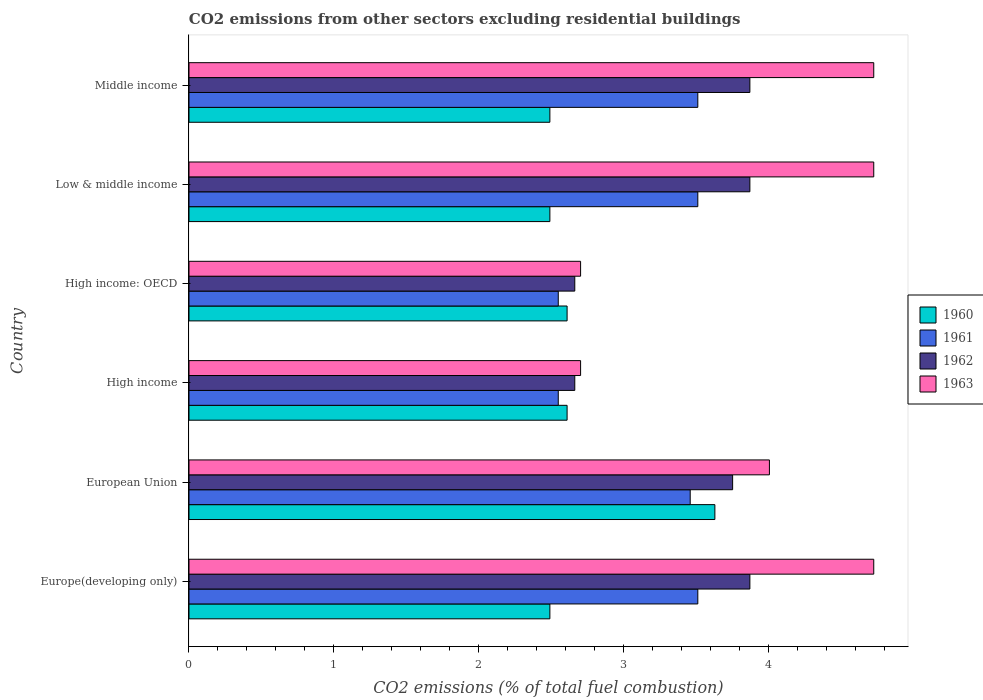How many different coloured bars are there?
Ensure brevity in your answer.  4. How many groups of bars are there?
Your answer should be compact. 6. Are the number of bars on each tick of the Y-axis equal?
Offer a terse response. Yes. How many bars are there on the 4th tick from the top?
Offer a terse response. 4. What is the label of the 1st group of bars from the top?
Make the answer very short. Middle income. What is the total CO2 emitted in 1961 in Middle income?
Provide a succinct answer. 3.51. Across all countries, what is the maximum total CO2 emitted in 1961?
Give a very brief answer. 3.51. Across all countries, what is the minimum total CO2 emitted in 1961?
Provide a short and direct response. 2.55. In which country was the total CO2 emitted in 1961 maximum?
Your response must be concise. Europe(developing only). What is the total total CO2 emitted in 1962 in the graph?
Keep it short and to the point. 20.69. What is the difference between the total CO2 emitted in 1960 in Europe(developing only) and that in High income: OECD?
Your response must be concise. -0.12. What is the difference between the total CO2 emitted in 1962 in High income and the total CO2 emitted in 1961 in Middle income?
Offer a terse response. -0.85. What is the average total CO2 emitted in 1963 per country?
Ensure brevity in your answer.  3.93. What is the difference between the total CO2 emitted in 1961 and total CO2 emitted in 1963 in European Union?
Offer a terse response. -0.55. What is the ratio of the total CO2 emitted in 1963 in High income: OECD to that in Low & middle income?
Provide a succinct answer. 0.57. Is the total CO2 emitted in 1961 in Europe(developing only) less than that in High income?
Make the answer very short. No. Is the difference between the total CO2 emitted in 1961 in European Union and Low & middle income greater than the difference between the total CO2 emitted in 1963 in European Union and Low & middle income?
Ensure brevity in your answer.  Yes. What is the difference between the highest and the second highest total CO2 emitted in 1963?
Offer a terse response. 0. What is the difference between the highest and the lowest total CO2 emitted in 1961?
Your answer should be compact. 0.96. In how many countries, is the total CO2 emitted in 1962 greater than the average total CO2 emitted in 1962 taken over all countries?
Offer a terse response. 4. Is it the case that in every country, the sum of the total CO2 emitted in 1962 and total CO2 emitted in 1961 is greater than the sum of total CO2 emitted in 1960 and total CO2 emitted in 1963?
Ensure brevity in your answer.  No. What does the 4th bar from the bottom in Europe(developing only) represents?
Ensure brevity in your answer.  1963. How many bars are there?
Offer a terse response. 24. How many countries are there in the graph?
Give a very brief answer. 6. What is the difference between two consecutive major ticks on the X-axis?
Your response must be concise. 1. Are the values on the major ticks of X-axis written in scientific E-notation?
Make the answer very short. No. Does the graph contain any zero values?
Offer a very short reply. No. Where does the legend appear in the graph?
Your response must be concise. Center right. How many legend labels are there?
Offer a terse response. 4. What is the title of the graph?
Your response must be concise. CO2 emissions from other sectors excluding residential buildings. Does "1967" appear as one of the legend labels in the graph?
Provide a succinct answer. No. What is the label or title of the X-axis?
Keep it short and to the point. CO2 emissions (% of total fuel combustion). What is the CO2 emissions (% of total fuel combustion) of 1960 in Europe(developing only)?
Offer a terse response. 2.49. What is the CO2 emissions (% of total fuel combustion) in 1961 in Europe(developing only)?
Your answer should be compact. 3.51. What is the CO2 emissions (% of total fuel combustion) in 1962 in Europe(developing only)?
Your response must be concise. 3.87. What is the CO2 emissions (% of total fuel combustion) of 1963 in Europe(developing only)?
Provide a short and direct response. 4.73. What is the CO2 emissions (% of total fuel combustion) of 1960 in European Union?
Provide a short and direct response. 3.63. What is the CO2 emissions (% of total fuel combustion) in 1961 in European Union?
Provide a short and direct response. 3.46. What is the CO2 emissions (% of total fuel combustion) of 1962 in European Union?
Ensure brevity in your answer.  3.75. What is the CO2 emissions (% of total fuel combustion) of 1963 in European Union?
Keep it short and to the point. 4.01. What is the CO2 emissions (% of total fuel combustion) in 1960 in High income?
Your answer should be compact. 2.61. What is the CO2 emissions (% of total fuel combustion) in 1961 in High income?
Your response must be concise. 2.55. What is the CO2 emissions (% of total fuel combustion) in 1962 in High income?
Make the answer very short. 2.66. What is the CO2 emissions (% of total fuel combustion) in 1963 in High income?
Your answer should be compact. 2.7. What is the CO2 emissions (% of total fuel combustion) of 1960 in High income: OECD?
Your answer should be compact. 2.61. What is the CO2 emissions (% of total fuel combustion) of 1961 in High income: OECD?
Make the answer very short. 2.55. What is the CO2 emissions (% of total fuel combustion) in 1962 in High income: OECD?
Provide a short and direct response. 2.66. What is the CO2 emissions (% of total fuel combustion) of 1963 in High income: OECD?
Make the answer very short. 2.7. What is the CO2 emissions (% of total fuel combustion) of 1960 in Low & middle income?
Your response must be concise. 2.49. What is the CO2 emissions (% of total fuel combustion) in 1961 in Low & middle income?
Keep it short and to the point. 3.51. What is the CO2 emissions (% of total fuel combustion) of 1962 in Low & middle income?
Make the answer very short. 3.87. What is the CO2 emissions (% of total fuel combustion) of 1963 in Low & middle income?
Make the answer very short. 4.73. What is the CO2 emissions (% of total fuel combustion) of 1960 in Middle income?
Offer a terse response. 2.49. What is the CO2 emissions (% of total fuel combustion) of 1961 in Middle income?
Ensure brevity in your answer.  3.51. What is the CO2 emissions (% of total fuel combustion) of 1962 in Middle income?
Your response must be concise. 3.87. What is the CO2 emissions (% of total fuel combustion) in 1963 in Middle income?
Provide a succinct answer. 4.73. Across all countries, what is the maximum CO2 emissions (% of total fuel combustion) in 1960?
Keep it short and to the point. 3.63. Across all countries, what is the maximum CO2 emissions (% of total fuel combustion) of 1961?
Keep it short and to the point. 3.51. Across all countries, what is the maximum CO2 emissions (% of total fuel combustion) of 1962?
Offer a terse response. 3.87. Across all countries, what is the maximum CO2 emissions (% of total fuel combustion) of 1963?
Provide a succinct answer. 4.73. Across all countries, what is the minimum CO2 emissions (% of total fuel combustion) in 1960?
Offer a very short reply. 2.49. Across all countries, what is the minimum CO2 emissions (% of total fuel combustion) of 1961?
Give a very brief answer. 2.55. Across all countries, what is the minimum CO2 emissions (% of total fuel combustion) of 1962?
Your response must be concise. 2.66. Across all countries, what is the minimum CO2 emissions (% of total fuel combustion) of 1963?
Provide a succinct answer. 2.7. What is the total CO2 emissions (% of total fuel combustion) in 1960 in the graph?
Make the answer very short. 16.32. What is the total CO2 emissions (% of total fuel combustion) in 1961 in the graph?
Your response must be concise. 19.09. What is the total CO2 emissions (% of total fuel combustion) of 1962 in the graph?
Provide a short and direct response. 20.69. What is the total CO2 emissions (% of total fuel combustion) in 1963 in the graph?
Provide a succinct answer. 23.59. What is the difference between the CO2 emissions (% of total fuel combustion) in 1960 in Europe(developing only) and that in European Union?
Provide a succinct answer. -1.14. What is the difference between the CO2 emissions (% of total fuel combustion) of 1961 in Europe(developing only) and that in European Union?
Provide a short and direct response. 0.05. What is the difference between the CO2 emissions (% of total fuel combustion) in 1962 in Europe(developing only) and that in European Union?
Provide a short and direct response. 0.12. What is the difference between the CO2 emissions (% of total fuel combustion) of 1963 in Europe(developing only) and that in European Union?
Offer a very short reply. 0.72. What is the difference between the CO2 emissions (% of total fuel combustion) of 1960 in Europe(developing only) and that in High income?
Offer a terse response. -0.12. What is the difference between the CO2 emissions (% of total fuel combustion) of 1961 in Europe(developing only) and that in High income?
Give a very brief answer. 0.96. What is the difference between the CO2 emissions (% of total fuel combustion) in 1962 in Europe(developing only) and that in High income?
Offer a terse response. 1.21. What is the difference between the CO2 emissions (% of total fuel combustion) of 1963 in Europe(developing only) and that in High income?
Offer a terse response. 2.02. What is the difference between the CO2 emissions (% of total fuel combustion) of 1960 in Europe(developing only) and that in High income: OECD?
Make the answer very short. -0.12. What is the difference between the CO2 emissions (% of total fuel combustion) of 1961 in Europe(developing only) and that in High income: OECD?
Offer a terse response. 0.96. What is the difference between the CO2 emissions (% of total fuel combustion) in 1962 in Europe(developing only) and that in High income: OECD?
Make the answer very short. 1.21. What is the difference between the CO2 emissions (% of total fuel combustion) in 1963 in Europe(developing only) and that in High income: OECD?
Give a very brief answer. 2.02. What is the difference between the CO2 emissions (% of total fuel combustion) of 1960 in Europe(developing only) and that in Low & middle income?
Provide a succinct answer. 0. What is the difference between the CO2 emissions (% of total fuel combustion) of 1962 in Europe(developing only) and that in Low & middle income?
Make the answer very short. 0. What is the difference between the CO2 emissions (% of total fuel combustion) of 1963 in Europe(developing only) and that in Low & middle income?
Provide a succinct answer. 0. What is the difference between the CO2 emissions (% of total fuel combustion) in 1961 in Europe(developing only) and that in Middle income?
Make the answer very short. 0. What is the difference between the CO2 emissions (% of total fuel combustion) of 1962 in Europe(developing only) and that in Middle income?
Give a very brief answer. 0. What is the difference between the CO2 emissions (% of total fuel combustion) in 1960 in European Union and that in High income?
Offer a very short reply. 1.02. What is the difference between the CO2 emissions (% of total fuel combustion) of 1961 in European Union and that in High income?
Give a very brief answer. 0.91. What is the difference between the CO2 emissions (% of total fuel combustion) of 1962 in European Union and that in High income?
Keep it short and to the point. 1.09. What is the difference between the CO2 emissions (% of total fuel combustion) of 1963 in European Union and that in High income?
Ensure brevity in your answer.  1.3. What is the difference between the CO2 emissions (% of total fuel combustion) of 1960 in European Union and that in High income: OECD?
Provide a short and direct response. 1.02. What is the difference between the CO2 emissions (% of total fuel combustion) in 1961 in European Union and that in High income: OECD?
Provide a succinct answer. 0.91. What is the difference between the CO2 emissions (% of total fuel combustion) in 1962 in European Union and that in High income: OECD?
Give a very brief answer. 1.09. What is the difference between the CO2 emissions (% of total fuel combustion) in 1963 in European Union and that in High income: OECD?
Offer a very short reply. 1.3. What is the difference between the CO2 emissions (% of total fuel combustion) in 1960 in European Union and that in Low & middle income?
Your answer should be very brief. 1.14. What is the difference between the CO2 emissions (% of total fuel combustion) of 1961 in European Union and that in Low & middle income?
Your answer should be compact. -0.05. What is the difference between the CO2 emissions (% of total fuel combustion) of 1962 in European Union and that in Low & middle income?
Keep it short and to the point. -0.12. What is the difference between the CO2 emissions (% of total fuel combustion) of 1963 in European Union and that in Low & middle income?
Make the answer very short. -0.72. What is the difference between the CO2 emissions (% of total fuel combustion) of 1960 in European Union and that in Middle income?
Offer a terse response. 1.14. What is the difference between the CO2 emissions (% of total fuel combustion) of 1961 in European Union and that in Middle income?
Keep it short and to the point. -0.05. What is the difference between the CO2 emissions (% of total fuel combustion) in 1962 in European Union and that in Middle income?
Offer a terse response. -0.12. What is the difference between the CO2 emissions (% of total fuel combustion) of 1963 in European Union and that in Middle income?
Give a very brief answer. -0.72. What is the difference between the CO2 emissions (% of total fuel combustion) of 1960 in High income and that in High income: OECD?
Provide a succinct answer. 0. What is the difference between the CO2 emissions (% of total fuel combustion) of 1962 in High income and that in High income: OECD?
Your answer should be very brief. 0. What is the difference between the CO2 emissions (% of total fuel combustion) in 1963 in High income and that in High income: OECD?
Your answer should be very brief. 0. What is the difference between the CO2 emissions (% of total fuel combustion) of 1960 in High income and that in Low & middle income?
Provide a short and direct response. 0.12. What is the difference between the CO2 emissions (% of total fuel combustion) of 1961 in High income and that in Low & middle income?
Keep it short and to the point. -0.96. What is the difference between the CO2 emissions (% of total fuel combustion) in 1962 in High income and that in Low & middle income?
Provide a succinct answer. -1.21. What is the difference between the CO2 emissions (% of total fuel combustion) of 1963 in High income and that in Low & middle income?
Offer a very short reply. -2.02. What is the difference between the CO2 emissions (% of total fuel combustion) in 1960 in High income and that in Middle income?
Your response must be concise. 0.12. What is the difference between the CO2 emissions (% of total fuel combustion) of 1961 in High income and that in Middle income?
Your answer should be compact. -0.96. What is the difference between the CO2 emissions (% of total fuel combustion) of 1962 in High income and that in Middle income?
Your answer should be very brief. -1.21. What is the difference between the CO2 emissions (% of total fuel combustion) in 1963 in High income and that in Middle income?
Your answer should be very brief. -2.02. What is the difference between the CO2 emissions (% of total fuel combustion) of 1960 in High income: OECD and that in Low & middle income?
Ensure brevity in your answer.  0.12. What is the difference between the CO2 emissions (% of total fuel combustion) in 1961 in High income: OECD and that in Low & middle income?
Make the answer very short. -0.96. What is the difference between the CO2 emissions (% of total fuel combustion) in 1962 in High income: OECD and that in Low & middle income?
Offer a terse response. -1.21. What is the difference between the CO2 emissions (% of total fuel combustion) in 1963 in High income: OECD and that in Low & middle income?
Ensure brevity in your answer.  -2.02. What is the difference between the CO2 emissions (% of total fuel combustion) in 1960 in High income: OECD and that in Middle income?
Give a very brief answer. 0.12. What is the difference between the CO2 emissions (% of total fuel combustion) of 1961 in High income: OECD and that in Middle income?
Provide a short and direct response. -0.96. What is the difference between the CO2 emissions (% of total fuel combustion) of 1962 in High income: OECD and that in Middle income?
Offer a terse response. -1.21. What is the difference between the CO2 emissions (% of total fuel combustion) in 1963 in High income: OECD and that in Middle income?
Your response must be concise. -2.02. What is the difference between the CO2 emissions (% of total fuel combustion) of 1960 in Low & middle income and that in Middle income?
Ensure brevity in your answer.  0. What is the difference between the CO2 emissions (% of total fuel combustion) of 1961 in Low & middle income and that in Middle income?
Offer a terse response. 0. What is the difference between the CO2 emissions (% of total fuel combustion) in 1963 in Low & middle income and that in Middle income?
Provide a succinct answer. 0. What is the difference between the CO2 emissions (% of total fuel combustion) of 1960 in Europe(developing only) and the CO2 emissions (% of total fuel combustion) of 1961 in European Union?
Your answer should be very brief. -0.97. What is the difference between the CO2 emissions (% of total fuel combustion) of 1960 in Europe(developing only) and the CO2 emissions (% of total fuel combustion) of 1962 in European Union?
Ensure brevity in your answer.  -1.26. What is the difference between the CO2 emissions (% of total fuel combustion) in 1960 in Europe(developing only) and the CO2 emissions (% of total fuel combustion) in 1963 in European Union?
Offer a terse response. -1.52. What is the difference between the CO2 emissions (% of total fuel combustion) of 1961 in Europe(developing only) and the CO2 emissions (% of total fuel combustion) of 1962 in European Union?
Keep it short and to the point. -0.24. What is the difference between the CO2 emissions (% of total fuel combustion) in 1961 in Europe(developing only) and the CO2 emissions (% of total fuel combustion) in 1963 in European Union?
Your response must be concise. -0.49. What is the difference between the CO2 emissions (% of total fuel combustion) of 1962 in Europe(developing only) and the CO2 emissions (% of total fuel combustion) of 1963 in European Union?
Make the answer very short. -0.14. What is the difference between the CO2 emissions (% of total fuel combustion) in 1960 in Europe(developing only) and the CO2 emissions (% of total fuel combustion) in 1961 in High income?
Make the answer very short. -0.06. What is the difference between the CO2 emissions (% of total fuel combustion) in 1960 in Europe(developing only) and the CO2 emissions (% of total fuel combustion) in 1962 in High income?
Make the answer very short. -0.17. What is the difference between the CO2 emissions (% of total fuel combustion) of 1960 in Europe(developing only) and the CO2 emissions (% of total fuel combustion) of 1963 in High income?
Offer a very short reply. -0.21. What is the difference between the CO2 emissions (% of total fuel combustion) in 1961 in Europe(developing only) and the CO2 emissions (% of total fuel combustion) in 1962 in High income?
Offer a terse response. 0.85. What is the difference between the CO2 emissions (% of total fuel combustion) of 1961 in Europe(developing only) and the CO2 emissions (% of total fuel combustion) of 1963 in High income?
Give a very brief answer. 0.81. What is the difference between the CO2 emissions (% of total fuel combustion) in 1962 in Europe(developing only) and the CO2 emissions (% of total fuel combustion) in 1963 in High income?
Ensure brevity in your answer.  1.17. What is the difference between the CO2 emissions (% of total fuel combustion) in 1960 in Europe(developing only) and the CO2 emissions (% of total fuel combustion) in 1961 in High income: OECD?
Keep it short and to the point. -0.06. What is the difference between the CO2 emissions (% of total fuel combustion) of 1960 in Europe(developing only) and the CO2 emissions (% of total fuel combustion) of 1962 in High income: OECD?
Your answer should be compact. -0.17. What is the difference between the CO2 emissions (% of total fuel combustion) in 1960 in Europe(developing only) and the CO2 emissions (% of total fuel combustion) in 1963 in High income: OECD?
Your response must be concise. -0.21. What is the difference between the CO2 emissions (% of total fuel combustion) of 1961 in Europe(developing only) and the CO2 emissions (% of total fuel combustion) of 1962 in High income: OECD?
Offer a very short reply. 0.85. What is the difference between the CO2 emissions (% of total fuel combustion) in 1961 in Europe(developing only) and the CO2 emissions (% of total fuel combustion) in 1963 in High income: OECD?
Make the answer very short. 0.81. What is the difference between the CO2 emissions (% of total fuel combustion) in 1962 in Europe(developing only) and the CO2 emissions (% of total fuel combustion) in 1963 in High income: OECD?
Give a very brief answer. 1.17. What is the difference between the CO2 emissions (% of total fuel combustion) of 1960 in Europe(developing only) and the CO2 emissions (% of total fuel combustion) of 1961 in Low & middle income?
Provide a succinct answer. -1.02. What is the difference between the CO2 emissions (% of total fuel combustion) in 1960 in Europe(developing only) and the CO2 emissions (% of total fuel combustion) in 1962 in Low & middle income?
Offer a terse response. -1.38. What is the difference between the CO2 emissions (% of total fuel combustion) of 1960 in Europe(developing only) and the CO2 emissions (% of total fuel combustion) of 1963 in Low & middle income?
Make the answer very short. -2.24. What is the difference between the CO2 emissions (% of total fuel combustion) in 1961 in Europe(developing only) and the CO2 emissions (% of total fuel combustion) in 1962 in Low & middle income?
Your response must be concise. -0.36. What is the difference between the CO2 emissions (% of total fuel combustion) of 1961 in Europe(developing only) and the CO2 emissions (% of total fuel combustion) of 1963 in Low & middle income?
Ensure brevity in your answer.  -1.21. What is the difference between the CO2 emissions (% of total fuel combustion) of 1962 in Europe(developing only) and the CO2 emissions (% of total fuel combustion) of 1963 in Low & middle income?
Offer a very short reply. -0.85. What is the difference between the CO2 emissions (% of total fuel combustion) of 1960 in Europe(developing only) and the CO2 emissions (% of total fuel combustion) of 1961 in Middle income?
Make the answer very short. -1.02. What is the difference between the CO2 emissions (% of total fuel combustion) of 1960 in Europe(developing only) and the CO2 emissions (% of total fuel combustion) of 1962 in Middle income?
Provide a short and direct response. -1.38. What is the difference between the CO2 emissions (% of total fuel combustion) in 1960 in Europe(developing only) and the CO2 emissions (% of total fuel combustion) in 1963 in Middle income?
Offer a terse response. -2.24. What is the difference between the CO2 emissions (% of total fuel combustion) in 1961 in Europe(developing only) and the CO2 emissions (% of total fuel combustion) in 1962 in Middle income?
Make the answer very short. -0.36. What is the difference between the CO2 emissions (% of total fuel combustion) of 1961 in Europe(developing only) and the CO2 emissions (% of total fuel combustion) of 1963 in Middle income?
Your answer should be very brief. -1.21. What is the difference between the CO2 emissions (% of total fuel combustion) of 1962 in Europe(developing only) and the CO2 emissions (% of total fuel combustion) of 1963 in Middle income?
Give a very brief answer. -0.85. What is the difference between the CO2 emissions (% of total fuel combustion) in 1960 in European Union and the CO2 emissions (% of total fuel combustion) in 1961 in High income?
Keep it short and to the point. 1.08. What is the difference between the CO2 emissions (% of total fuel combustion) of 1960 in European Union and the CO2 emissions (% of total fuel combustion) of 1962 in High income?
Make the answer very short. 0.97. What is the difference between the CO2 emissions (% of total fuel combustion) of 1960 in European Union and the CO2 emissions (% of total fuel combustion) of 1963 in High income?
Your answer should be compact. 0.93. What is the difference between the CO2 emissions (% of total fuel combustion) of 1961 in European Union and the CO2 emissions (% of total fuel combustion) of 1962 in High income?
Provide a succinct answer. 0.8. What is the difference between the CO2 emissions (% of total fuel combustion) of 1961 in European Union and the CO2 emissions (% of total fuel combustion) of 1963 in High income?
Offer a terse response. 0.76. What is the difference between the CO2 emissions (% of total fuel combustion) in 1962 in European Union and the CO2 emissions (% of total fuel combustion) in 1963 in High income?
Keep it short and to the point. 1.05. What is the difference between the CO2 emissions (% of total fuel combustion) in 1960 in European Union and the CO2 emissions (% of total fuel combustion) in 1961 in High income: OECD?
Provide a short and direct response. 1.08. What is the difference between the CO2 emissions (% of total fuel combustion) in 1960 in European Union and the CO2 emissions (% of total fuel combustion) in 1963 in High income: OECD?
Ensure brevity in your answer.  0.93. What is the difference between the CO2 emissions (% of total fuel combustion) of 1961 in European Union and the CO2 emissions (% of total fuel combustion) of 1962 in High income: OECD?
Offer a very short reply. 0.8. What is the difference between the CO2 emissions (% of total fuel combustion) in 1961 in European Union and the CO2 emissions (% of total fuel combustion) in 1963 in High income: OECD?
Your answer should be compact. 0.76. What is the difference between the CO2 emissions (% of total fuel combustion) in 1962 in European Union and the CO2 emissions (% of total fuel combustion) in 1963 in High income: OECD?
Your response must be concise. 1.05. What is the difference between the CO2 emissions (% of total fuel combustion) in 1960 in European Union and the CO2 emissions (% of total fuel combustion) in 1961 in Low & middle income?
Provide a succinct answer. 0.12. What is the difference between the CO2 emissions (% of total fuel combustion) of 1960 in European Union and the CO2 emissions (% of total fuel combustion) of 1962 in Low & middle income?
Provide a short and direct response. -0.24. What is the difference between the CO2 emissions (% of total fuel combustion) in 1960 in European Union and the CO2 emissions (% of total fuel combustion) in 1963 in Low & middle income?
Your response must be concise. -1.1. What is the difference between the CO2 emissions (% of total fuel combustion) of 1961 in European Union and the CO2 emissions (% of total fuel combustion) of 1962 in Low & middle income?
Offer a very short reply. -0.41. What is the difference between the CO2 emissions (% of total fuel combustion) of 1961 in European Union and the CO2 emissions (% of total fuel combustion) of 1963 in Low & middle income?
Keep it short and to the point. -1.27. What is the difference between the CO2 emissions (% of total fuel combustion) in 1962 in European Union and the CO2 emissions (% of total fuel combustion) in 1963 in Low & middle income?
Provide a short and direct response. -0.97. What is the difference between the CO2 emissions (% of total fuel combustion) of 1960 in European Union and the CO2 emissions (% of total fuel combustion) of 1961 in Middle income?
Your answer should be compact. 0.12. What is the difference between the CO2 emissions (% of total fuel combustion) in 1960 in European Union and the CO2 emissions (% of total fuel combustion) in 1962 in Middle income?
Make the answer very short. -0.24. What is the difference between the CO2 emissions (% of total fuel combustion) of 1960 in European Union and the CO2 emissions (% of total fuel combustion) of 1963 in Middle income?
Make the answer very short. -1.1. What is the difference between the CO2 emissions (% of total fuel combustion) in 1961 in European Union and the CO2 emissions (% of total fuel combustion) in 1962 in Middle income?
Your answer should be compact. -0.41. What is the difference between the CO2 emissions (% of total fuel combustion) in 1961 in European Union and the CO2 emissions (% of total fuel combustion) in 1963 in Middle income?
Make the answer very short. -1.27. What is the difference between the CO2 emissions (% of total fuel combustion) of 1962 in European Union and the CO2 emissions (% of total fuel combustion) of 1963 in Middle income?
Provide a succinct answer. -0.97. What is the difference between the CO2 emissions (% of total fuel combustion) of 1960 in High income and the CO2 emissions (% of total fuel combustion) of 1961 in High income: OECD?
Your answer should be compact. 0.06. What is the difference between the CO2 emissions (% of total fuel combustion) of 1960 in High income and the CO2 emissions (% of total fuel combustion) of 1962 in High income: OECD?
Your response must be concise. -0.05. What is the difference between the CO2 emissions (% of total fuel combustion) in 1960 in High income and the CO2 emissions (% of total fuel combustion) in 1963 in High income: OECD?
Keep it short and to the point. -0.09. What is the difference between the CO2 emissions (% of total fuel combustion) of 1961 in High income and the CO2 emissions (% of total fuel combustion) of 1962 in High income: OECD?
Offer a very short reply. -0.11. What is the difference between the CO2 emissions (% of total fuel combustion) of 1961 in High income and the CO2 emissions (% of total fuel combustion) of 1963 in High income: OECD?
Give a very brief answer. -0.15. What is the difference between the CO2 emissions (% of total fuel combustion) of 1962 in High income and the CO2 emissions (% of total fuel combustion) of 1963 in High income: OECD?
Your answer should be very brief. -0.04. What is the difference between the CO2 emissions (% of total fuel combustion) in 1960 in High income and the CO2 emissions (% of total fuel combustion) in 1961 in Low & middle income?
Provide a succinct answer. -0.9. What is the difference between the CO2 emissions (% of total fuel combustion) of 1960 in High income and the CO2 emissions (% of total fuel combustion) of 1962 in Low & middle income?
Ensure brevity in your answer.  -1.26. What is the difference between the CO2 emissions (% of total fuel combustion) of 1960 in High income and the CO2 emissions (% of total fuel combustion) of 1963 in Low & middle income?
Your answer should be very brief. -2.12. What is the difference between the CO2 emissions (% of total fuel combustion) of 1961 in High income and the CO2 emissions (% of total fuel combustion) of 1962 in Low & middle income?
Your answer should be compact. -1.32. What is the difference between the CO2 emissions (% of total fuel combustion) in 1961 in High income and the CO2 emissions (% of total fuel combustion) in 1963 in Low & middle income?
Offer a very short reply. -2.18. What is the difference between the CO2 emissions (% of total fuel combustion) of 1962 in High income and the CO2 emissions (% of total fuel combustion) of 1963 in Low & middle income?
Your answer should be very brief. -2.06. What is the difference between the CO2 emissions (% of total fuel combustion) of 1960 in High income and the CO2 emissions (% of total fuel combustion) of 1961 in Middle income?
Your answer should be very brief. -0.9. What is the difference between the CO2 emissions (% of total fuel combustion) of 1960 in High income and the CO2 emissions (% of total fuel combustion) of 1962 in Middle income?
Make the answer very short. -1.26. What is the difference between the CO2 emissions (% of total fuel combustion) of 1960 in High income and the CO2 emissions (% of total fuel combustion) of 1963 in Middle income?
Make the answer very short. -2.12. What is the difference between the CO2 emissions (% of total fuel combustion) in 1961 in High income and the CO2 emissions (% of total fuel combustion) in 1962 in Middle income?
Your answer should be compact. -1.32. What is the difference between the CO2 emissions (% of total fuel combustion) in 1961 in High income and the CO2 emissions (% of total fuel combustion) in 1963 in Middle income?
Your response must be concise. -2.18. What is the difference between the CO2 emissions (% of total fuel combustion) of 1962 in High income and the CO2 emissions (% of total fuel combustion) of 1963 in Middle income?
Give a very brief answer. -2.06. What is the difference between the CO2 emissions (% of total fuel combustion) in 1960 in High income: OECD and the CO2 emissions (% of total fuel combustion) in 1961 in Low & middle income?
Keep it short and to the point. -0.9. What is the difference between the CO2 emissions (% of total fuel combustion) in 1960 in High income: OECD and the CO2 emissions (% of total fuel combustion) in 1962 in Low & middle income?
Provide a short and direct response. -1.26. What is the difference between the CO2 emissions (% of total fuel combustion) of 1960 in High income: OECD and the CO2 emissions (% of total fuel combustion) of 1963 in Low & middle income?
Your answer should be compact. -2.12. What is the difference between the CO2 emissions (% of total fuel combustion) in 1961 in High income: OECD and the CO2 emissions (% of total fuel combustion) in 1962 in Low & middle income?
Provide a succinct answer. -1.32. What is the difference between the CO2 emissions (% of total fuel combustion) in 1961 in High income: OECD and the CO2 emissions (% of total fuel combustion) in 1963 in Low & middle income?
Ensure brevity in your answer.  -2.18. What is the difference between the CO2 emissions (% of total fuel combustion) in 1962 in High income: OECD and the CO2 emissions (% of total fuel combustion) in 1963 in Low & middle income?
Your response must be concise. -2.06. What is the difference between the CO2 emissions (% of total fuel combustion) in 1960 in High income: OECD and the CO2 emissions (% of total fuel combustion) in 1961 in Middle income?
Your answer should be compact. -0.9. What is the difference between the CO2 emissions (% of total fuel combustion) of 1960 in High income: OECD and the CO2 emissions (% of total fuel combustion) of 1962 in Middle income?
Provide a succinct answer. -1.26. What is the difference between the CO2 emissions (% of total fuel combustion) of 1960 in High income: OECD and the CO2 emissions (% of total fuel combustion) of 1963 in Middle income?
Provide a succinct answer. -2.12. What is the difference between the CO2 emissions (% of total fuel combustion) of 1961 in High income: OECD and the CO2 emissions (% of total fuel combustion) of 1962 in Middle income?
Offer a very short reply. -1.32. What is the difference between the CO2 emissions (% of total fuel combustion) in 1961 in High income: OECD and the CO2 emissions (% of total fuel combustion) in 1963 in Middle income?
Your answer should be compact. -2.18. What is the difference between the CO2 emissions (% of total fuel combustion) in 1962 in High income: OECD and the CO2 emissions (% of total fuel combustion) in 1963 in Middle income?
Keep it short and to the point. -2.06. What is the difference between the CO2 emissions (% of total fuel combustion) of 1960 in Low & middle income and the CO2 emissions (% of total fuel combustion) of 1961 in Middle income?
Offer a terse response. -1.02. What is the difference between the CO2 emissions (% of total fuel combustion) in 1960 in Low & middle income and the CO2 emissions (% of total fuel combustion) in 1962 in Middle income?
Your answer should be compact. -1.38. What is the difference between the CO2 emissions (% of total fuel combustion) of 1960 in Low & middle income and the CO2 emissions (% of total fuel combustion) of 1963 in Middle income?
Provide a short and direct response. -2.24. What is the difference between the CO2 emissions (% of total fuel combustion) in 1961 in Low & middle income and the CO2 emissions (% of total fuel combustion) in 1962 in Middle income?
Ensure brevity in your answer.  -0.36. What is the difference between the CO2 emissions (% of total fuel combustion) in 1961 in Low & middle income and the CO2 emissions (% of total fuel combustion) in 1963 in Middle income?
Provide a succinct answer. -1.21. What is the difference between the CO2 emissions (% of total fuel combustion) in 1962 in Low & middle income and the CO2 emissions (% of total fuel combustion) in 1963 in Middle income?
Your answer should be very brief. -0.85. What is the average CO2 emissions (% of total fuel combustion) of 1960 per country?
Ensure brevity in your answer.  2.72. What is the average CO2 emissions (% of total fuel combustion) of 1961 per country?
Make the answer very short. 3.18. What is the average CO2 emissions (% of total fuel combustion) in 1962 per country?
Provide a short and direct response. 3.45. What is the average CO2 emissions (% of total fuel combustion) of 1963 per country?
Offer a very short reply. 3.93. What is the difference between the CO2 emissions (% of total fuel combustion) of 1960 and CO2 emissions (% of total fuel combustion) of 1961 in Europe(developing only)?
Make the answer very short. -1.02. What is the difference between the CO2 emissions (% of total fuel combustion) in 1960 and CO2 emissions (% of total fuel combustion) in 1962 in Europe(developing only)?
Provide a short and direct response. -1.38. What is the difference between the CO2 emissions (% of total fuel combustion) of 1960 and CO2 emissions (% of total fuel combustion) of 1963 in Europe(developing only)?
Keep it short and to the point. -2.24. What is the difference between the CO2 emissions (% of total fuel combustion) of 1961 and CO2 emissions (% of total fuel combustion) of 1962 in Europe(developing only)?
Provide a short and direct response. -0.36. What is the difference between the CO2 emissions (% of total fuel combustion) in 1961 and CO2 emissions (% of total fuel combustion) in 1963 in Europe(developing only)?
Keep it short and to the point. -1.21. What is the difference between the CO2 emissions (% of total fuel combustion) in 1962 and CO2 emissions (% of total fuel combustion) in 1963 in Europe(developing only)?
Make the answer very short. -0.85. What is the difference between the CO2 emissions (% of total fuel combustion) of 1960 and CO2 emissions (% of total fuel combustion) of 1961 in European Union?
Ensure brevity in your answer.  0.17. What is the difference between the CO2 emissions (% of total fuel combustion) of 1960 and CO2 emissions (% of total fuel combustion) of 1962 in European Union?
Your answer should be compact. -0.12. What is the difference between the CO2 emissions (% of total fuel combustion) in 1960 and CO2 emissions (% of total fuel combustion) in 1963 in European Union?
Ensure brevity in your answer.  -0.38. What is the difference between the CO2 emissions (% of total fuel combustion) in 1961 and CO2 emissions (% of total fuel combustion) in 1962 in European Union?
Provide a succinct answer. -0.29. What is the difference between the CO2 emissions (% of total fuel combustion) of 1961 and CO2 emissions (% of total fuel combustion) of 1963 in European Union?
Your answer should be compact. -0.55. What is the difference between the CO2 emissions (% of total fuel combustion) of 1962 and CO2 emissions (% of total fuel combustion) of 1963 in European Union?
Offer a very short reply. -0.25. What is the difference between the CO2 emissions (% of total fuel combustion) in 1960 and CO2 emissions (% of total fuel combustion) in 1961 in High income?
Give a very brief answer. 0.06. What is the difference between the CO2 emissions (% of total fuel combustion) in 1960 and CO2 emissions (% of total fuel combustion) in 1962 in High income?
Provide a short and direct response. -0.05. What is the difference between the CO2 emissions (% of total fuel combustion) in 1960 and CO2 emissions (% of total fuel combustion) in 1963 in High income?
Offer a terse response. -0.09. What is the difference between the CO2 emissions (% of total fuel combustion) in 1961 and CO2 emissions (% of total fuel combustion) in 1962 in High income?
Your answer should be compact. -0.11. What is the difference between the CO2 emissions (% of total fuel combustion) of 1961 and CO2 emissions (% of total fuel combustion) of 1963 in High income?
Keep it short and to the point. -0.15. What is the difference between the CO2 emissions (% of total fuel combustion) of 1962 and CO2 emissions (% of total fuel combustion) of 1963 in High income?
Your answer should be compact. -0.04. What is the difference between the CO2 emissions (% of total fuel combustion) of 1960 and CO2 emissions (% of total fuel combustion) of 1961 in High income: OECD?
Ensure brevity in your answer.  0.06. What is the difference between the CO2 emissions (% of total fuel combustion) of 1960 and CO2 emissions (% of total fuel combustion) of 1962 in High income: OECD?
Your answer should be compact. -0.05. What is the difference between the CO2 emissions (% of total fuel combustion) in 1960 and CO2 emissions (% of total fuel combustion) in 1963 in High income: OECD?
Your response must be concise. -0.09. What is the difference between the CO2 emissions (% of total fuel combustion) in 1961 and CO2 emissions (% of total fuel combustion) in 1962 in High income: OECD?
Provide a short and direct response. -0.11. What is the difference between the CO2 emissions (% of total fuel combustion) of 1961 and CO2 emissions (% of total fuel combustion) of 1963 in High income: OECD?
Provide a succinct answer. -0.15. What is the difference between the CO2 emissions (% of total fuel combustion) in 1962 and CO2 emissions (% of total fuel combustion) in 1963 in High income: OECD?
Ensure brevity in your answer.  -0.04. What is the difference between the CO2 emissions (% of total fuel combustion) of 1960 and CO2 emissions (% of total fuel combustion) of 1961 in Low & middle income?
Ensure brevity in your answer.  -1.02. What is the difference between the CO2 emissions (% of total fuel combustion) of 1960 and CO2 emissions (% of total fuel combustion) of 1962 in Low & middle income?
Keep it short and to the point. -1.38. What is the difference between the CO2 emissions (% of total fuel combustion) of 1960 and CO2 emissions (% of total fuel combustion) of 1963 in Low & middle income?
Offer a terse response. -2.24. What is the difference between the CO2 emissions (% of total fuel combustion) in 1961 and CO2 emissions (% of total fuel combustion) in 1962 in Low & middle income?
Ensure brevity in your answer.  -0.36. What is the difference between the CO2 emissions (% of total fuel combustion) in 1961 and CO2 emissions (% of total fuel combustion) in 1963 in Low & middle income?
Your answer should be compact. -1.21. What is the difference between the CO2 emissions (% of total fuel combustion) in 1962 and CO2 emissions (% of total fuel combustion) in 1963 in Low & middle income?
Keep it short and to the point. -0.85. What is the difference between the CO2 emissions (% of total fuel combustion) in 1960 and CO2 emissions (% of total fuel combustion) in 1961 in Middle income?
Keep it short and to the point. -1.02. What is the difference between the CO2 emissions (% of total fuel combustion) in 1960 and CO2 emissions (% of total fuel combustion) in 1962 in Middle income?
Ensure brevity in your answer.  -1.38. What is the difference between the CO2 emissions (% of total fuel combustion) in 1960 and CO2 emissions (% of total fuel combustion) in 1963 in Middle income?
Offer a very short reply. -2.24. What is the difference between the CO2 emissions (% of total fuel combustion) of 1961 and CO2 emissions (% of total fuel combustion) of 1962 in Middle income?
Offer a terse response. -0.36. What is the difference between the CO2 emissions (% of total fuel combustion) in 1961 and CO2 emissions (% of total fuel combustion) in 1963 in Middle income?
Offer a terse response. -1.21. What is the difference between the CO2 emissions (% of total fuel combustion) in 1962 and CO2 emissions (% of total fuel combustion) in 1963 in Middle income?
Your answer should be compact. -0.85. What is the ratio of the CO2 emissions (% of total fuel combustion) in 1960 in Europe(developing only) to that in European Union?
Your answer should be compact. 0.69. What is the ratio of the CO2 emissions (% of total fuel combustion) of 1961 in Europe(developing only) to that in European Union?
Your response must be concise. 1.02. What is the ratio of the CO2 emissions (% of total fuel combustion) of 1962 in Europe(developing only) to that in European Union?
Offer a terse response. 1.03. What is the ratio of the CO2 emissions (% of total fuel combustion) of 1963 in Europe(developing only) to that in European Union?
Make the answer very short. 1.18. What is the ratio of the CO2 emissions (% of total fuel combustion) of 1960 in Europe(developing only) to that in High income?
Your answer should be very brief. 0.95. What is the ratio of the CO2 emissions (% of total fuel combustion) of 1961 in Europe(developing only) to that in High income?
Offer a very short reply. 1.38. What is the ratio of the CO2 emissions (% of total fuel combustion) in 1962 in Europe(developing only) to that in High income?
Keep it short and to the point. 1.45. What is the ratio of the CO2 emissions (% of total fuel combustion) of 1963 in Europe(developing only) to that in High income?
Offer a very short reply. 1.75. What is the ratio of the CO2 emissions (% of total fuel combustion) in 1960 in Europe(developing only) to that in High income: OECD?
Keep it short and to the point. 0.95. What is the ratio of the CO2 emissions (% of total fuel combustion) in 1961 in Europe(developing only) to that in High income: OECD?
Your response must be concise. 1.38. What is the ratio of the CO2 emissions (% of total fuel combustion) in 1962 in Europe(developing only) to that in High income: OECD?
Provide a short and direct response. 1.45. What is the ratio of the CO2 emissions (% of total fuel combustion) of 1963 in Europe(developing only) to that in High income: OECD?
Offer a terse response. 1.75. What is the ratio of the CO2 emissions (% of total fuel combustion) in 1960 in Europe(developing only) to that in Low & middle income?
Provide a succinct answer. 1. What is the ratio of the CO2 emissions (% of total fuel combustion) of 1962 in Europe(developing only) to that in Low & middle income?
Ensure brevity in your answer.  1. What is the ratio of the CO2 emissions (% of total fuel combustion) of 1963 in Europe(developing only) to that in Low & middle income?
Make the answer very short. 1. What is the ratio of the CO2 emissions (% of total fuel combustion) of 1960 in Europe(developing only) to that in Middle income?
Provide a short and direct response. 1. What is the ratio of the CO2 emissions (% of total fuel combustion) in 1961 in Europe(developing only) to that in Middle income?
Ensure brevity in your answer.  1. What is the ratio of the CO2 emissions (% of total fuel combustion) in 1962 in Europe(developing only) to that in Middle income?
Keep it short and to the point. 1. What is the ratio of the CO2 emissions (% of total fuel combustion) in 1963 in Europe(developing only) to that in Middle income?
Offer a terse response. 1. What is the ratio of the CO2 emissions (% of total fuel combustion) of 1960 in European Union to that in High income?
Ensure brevity in your answer.  1.39. What is the ratio of the CO2 emissions (% of total fuel combustion) in 1961 in European Union to that in High income?
Ensure brevity in your answer.  1.36. What is the ratio of the CO2 emissions (% of total fuel combustion) in 1962 in European Union to that in High income?
Provide a succinct answer. 1.41. What is the ratio of the CO2 emissions (% of total fuel combustion) in 1963 in European Union to that in High income?
Ensure brevity in your answer.  1.48. What is the ratio of the CO2 emissions (% of total fuel combustion) of 1960 in European Union to that in High income: OECD?
Keep it short and to the point. 1.39. What is the ratio of the CO2 emissions (% of total fuel combustion) of 1961 in European Union to that in High income: OECD?
Make the answer very short. 1.36. What is the ratio of the CO2 emissions (% of total fuel combustion) in 1962 in European Union to that in High income: OECD?
Provide a short and direct response. 1.41. What is the ratio of the CO2 emissions (% of total fuel combustion) of 1963 in European Union to that in High income: OECD?
Provide a succinct answer. 1.48. What is the ratio of the CO2 emissions (% of total fuel combustion) in 1960 in European Union to that in Low & middle income?
Give a very brief answer. 1.46. What is the ratio of the CO2 emissions (% of total fuel combustion) in 1962 in European Union to that in Low & middle income?
Ensure brevity in your answer.  0.97. What is the ratio of the CO2 emissions (% of total fuel combustion) of 1963 in European Union to that in Low & middle income?
Offer a very short reply. 0.85. What is the ratio of the CO2 emissions (% of total fuel combustion) of 1960 in European Union to that in Middle income?
Your answer should be very brief. 1.46. What is the ratio of the CO2 emissions (% of total fuel combustion) of 1962 in European Union to that in Middle income?
Keep it short and to the point. 0.97. What is the ratio of the CO2 emissions (% of total fuel combustion) in 1963 in European Union to that in Middle income?
Your answer should be compact. 0.85. What is the ratio of the CO2 emissions (% of total fuel combustion) of 1960 in High income to that in High income: OECD?
Ensure brevity in your answer.  1. What is the ratio of the CO2 emissions (% of total fuel combustion) in 1962 in High income to that in High income: OECD?
Offer a terse response. 1. What is the ratio of the CO2 emissions (% of total fuel combustion) in 1960 in High income to that in Low & middle income?
Keep it short and to the point. 1.05. What is the ratio of the CO2 emissions (% of total fuel combustion) in 1961 in High income to that in Low & middle income?
Offer a terse response. 0.73. What is the ratio of the CO2 emissions (% of total fuel combustion) in 1962 in High income to that in Low & middle income?
Offer a terse response. 0.69. What is the ratio of the CO2 emissions (% of total fuel combustion) of 1963 in High income to that in Low & middle income?
Offer a very short reply. 0.57. What is the ratio of the CO2 emissions (% of total fuel combustion) of 1960 in High income to that in Middle income?
Your answer should be very brief. 1.05. What is the ratio of the CO2 emissions (% of total fuel combustion) of 1961 in High income to that in Middle income?
Provide a succinct answer. 0.73. What is the ratio of the CO2 emissions (% of total fuel combustion) of 1962 in High income to that in Middle income?
Ensure brevity in your answer.  0.69. What is the ratio of the CO2 emissions (% of total fuel combustion) in 1963 in High income to that in Middle income?
Ensure brevity in your answer.  0.57. What is the ratio of the CO2 emissions (% of total fuel combustion) of 1960 in High income: OECD to that in Low & middle income?
Provide a succinct answer. 1.05. What is the ratio of the CO2 emissions (% of total fuel combustion) of 1961 in High income: OECD to that in Low & middle income?
Offer a terse response. 0.73. What is the ratio of the CO2 emissions (% of total fuel combustion) in 1962 in High income: OECD to that in Low & middle income?
Your response must be concise. 0.69. What is the ratio of the CO2 emissions (% of total fuel combustion) of 1963 in High income: OECD to that in Low & middle income?
Your answer should be compact. 0.57. What is the ratio of the CO2 emissions (% of total fuel combustion) in 1960 in High income: OECD to that in Middle income?
Give a very brief answer. 1.05. What is the ratio of the CO2 emissions (% of total fuel combustion) of 1961 in High income: OECD to that in Middle income?
Give a very brief answer. 0.73. What is the ratio of the CO2 emissions (% of total fuel combustion) of 1962 in High income: OECD to that in Middle income?
Ensure brevity in your answer.  0.69. What is the ratio of the CO2 emissions (% of total fuel combustion) in 1963 in High income: OECD to that in Middle income?
Your response must be concise. 0.57. What is the difference between the highest and the second highest CO2 emissions (% of total fuel combustion) of 1961?
Provide a succinct answer. 0. What is the difference between the highest and the second highest CO2 emissions (% of total fuel combustion) in 1962?
Ensure brevity in your answer.  0. What is the difference between the highest and the second highest CO2 emissions (% of total fuel combustion) in 1963?
Your response must be concise. 0. What is the difference between the highest and the lowest CO2 emissions (% of total fuel combustion) of 1960?
Offer a terse response. 1.14. What is the difference between the highest and the lowest CO2 emissions (% of total fuel combustion) of 1961?
Your response must be concise. 0.96. What is the difference between the highest and the lowest CO2 emissions (% of total fuel combustion) of 1962?
Provide a succinct answer. 1.21. What is the difference between the highest and the lowest CO2 emissions (% of total fuel combustion) in 1963?
Your answer should be very brief. 2.02. 